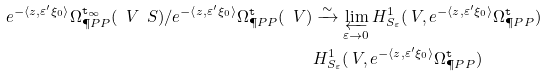<formula> <loc_0><loc_0><loc_500><loc_500>e ^ { - \langle z , \varepsilon ^ { \prime } \xi _ { 0 } \rangle } \Omega ^ { \tt t _ { \infty } } _ { \P P P } ( \ V \ S ) / e ^ { - \langle z , \varepsilon ^ { \prime } \xi _ { 0 } \rangle } \Omega ^ { \tt t } _ { \P P P } ( \ V ) & \xrightarrow { \sim } \varprojlim _ { \varepsilon \to 0 } H ^ { 1 } _ { S _ { \varepsilon } } ( \ V , e ^ { - \langle z , \varepsilon ^ { \prime } \xi _ { 0 } \rangle } \Omega _ { \P P P } ^ { \tt t } ) \\ & H ^ { 1 } _ { S _ { \varepsilon } } ( \ V , e ^ { - \langle z , \varepsilon ^ { \prime } \xi _ { 0 } \rangle } \Omega _ { \P P P } ^ { \tt t } )</formula> 